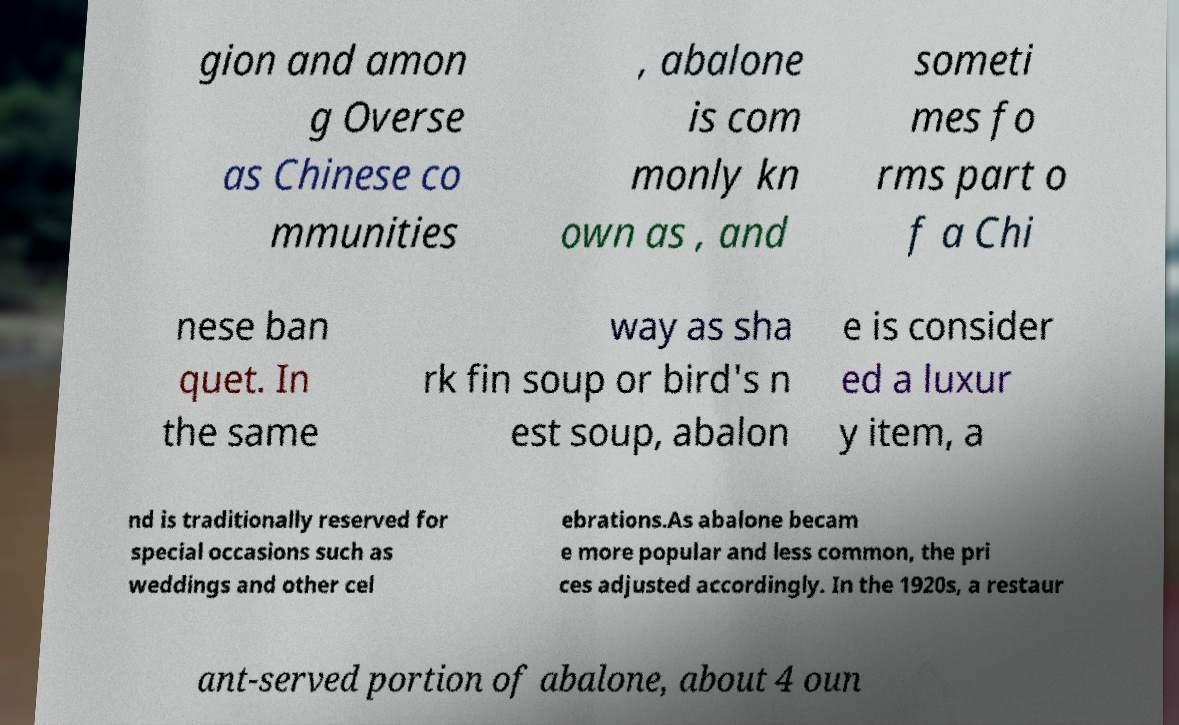Could you assist in decoding the text presented in this image and type it out clearly? gion and amon g Overse as Chinese co mmunities , abalone is com monly kn own as , and someti mes fo rms part o f a Chi nese ban quet. In the same way as sha rk fin soup or bird's n est soup, abalon e is consider ed a luxur y item, a nd is traditionally reserved for special occasions such as weddings and other cel ebrations.As abalone becam e more popular and less common, the pri ces adjusted accordingly. In the 1920s, a restaur ant-served portion of abalone, about 4 oun 